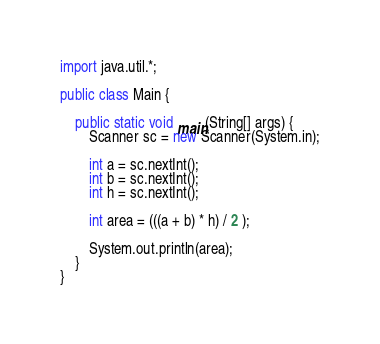<code> <loc_0><loc_0><loc_500><loc_500><_Java_>import java.util.*;

public class Main {
	
	public static void main(String[] args) {
		Scanner sc = new Scanner(System.in);
      
        int a = sc.nextInt();
        int b = sc.nextInt();
        int h = sc.nextInt();
      
        int area = (((a + b) * h) / 2 );
          
        System.out.println(area);
	} 
}</code> 